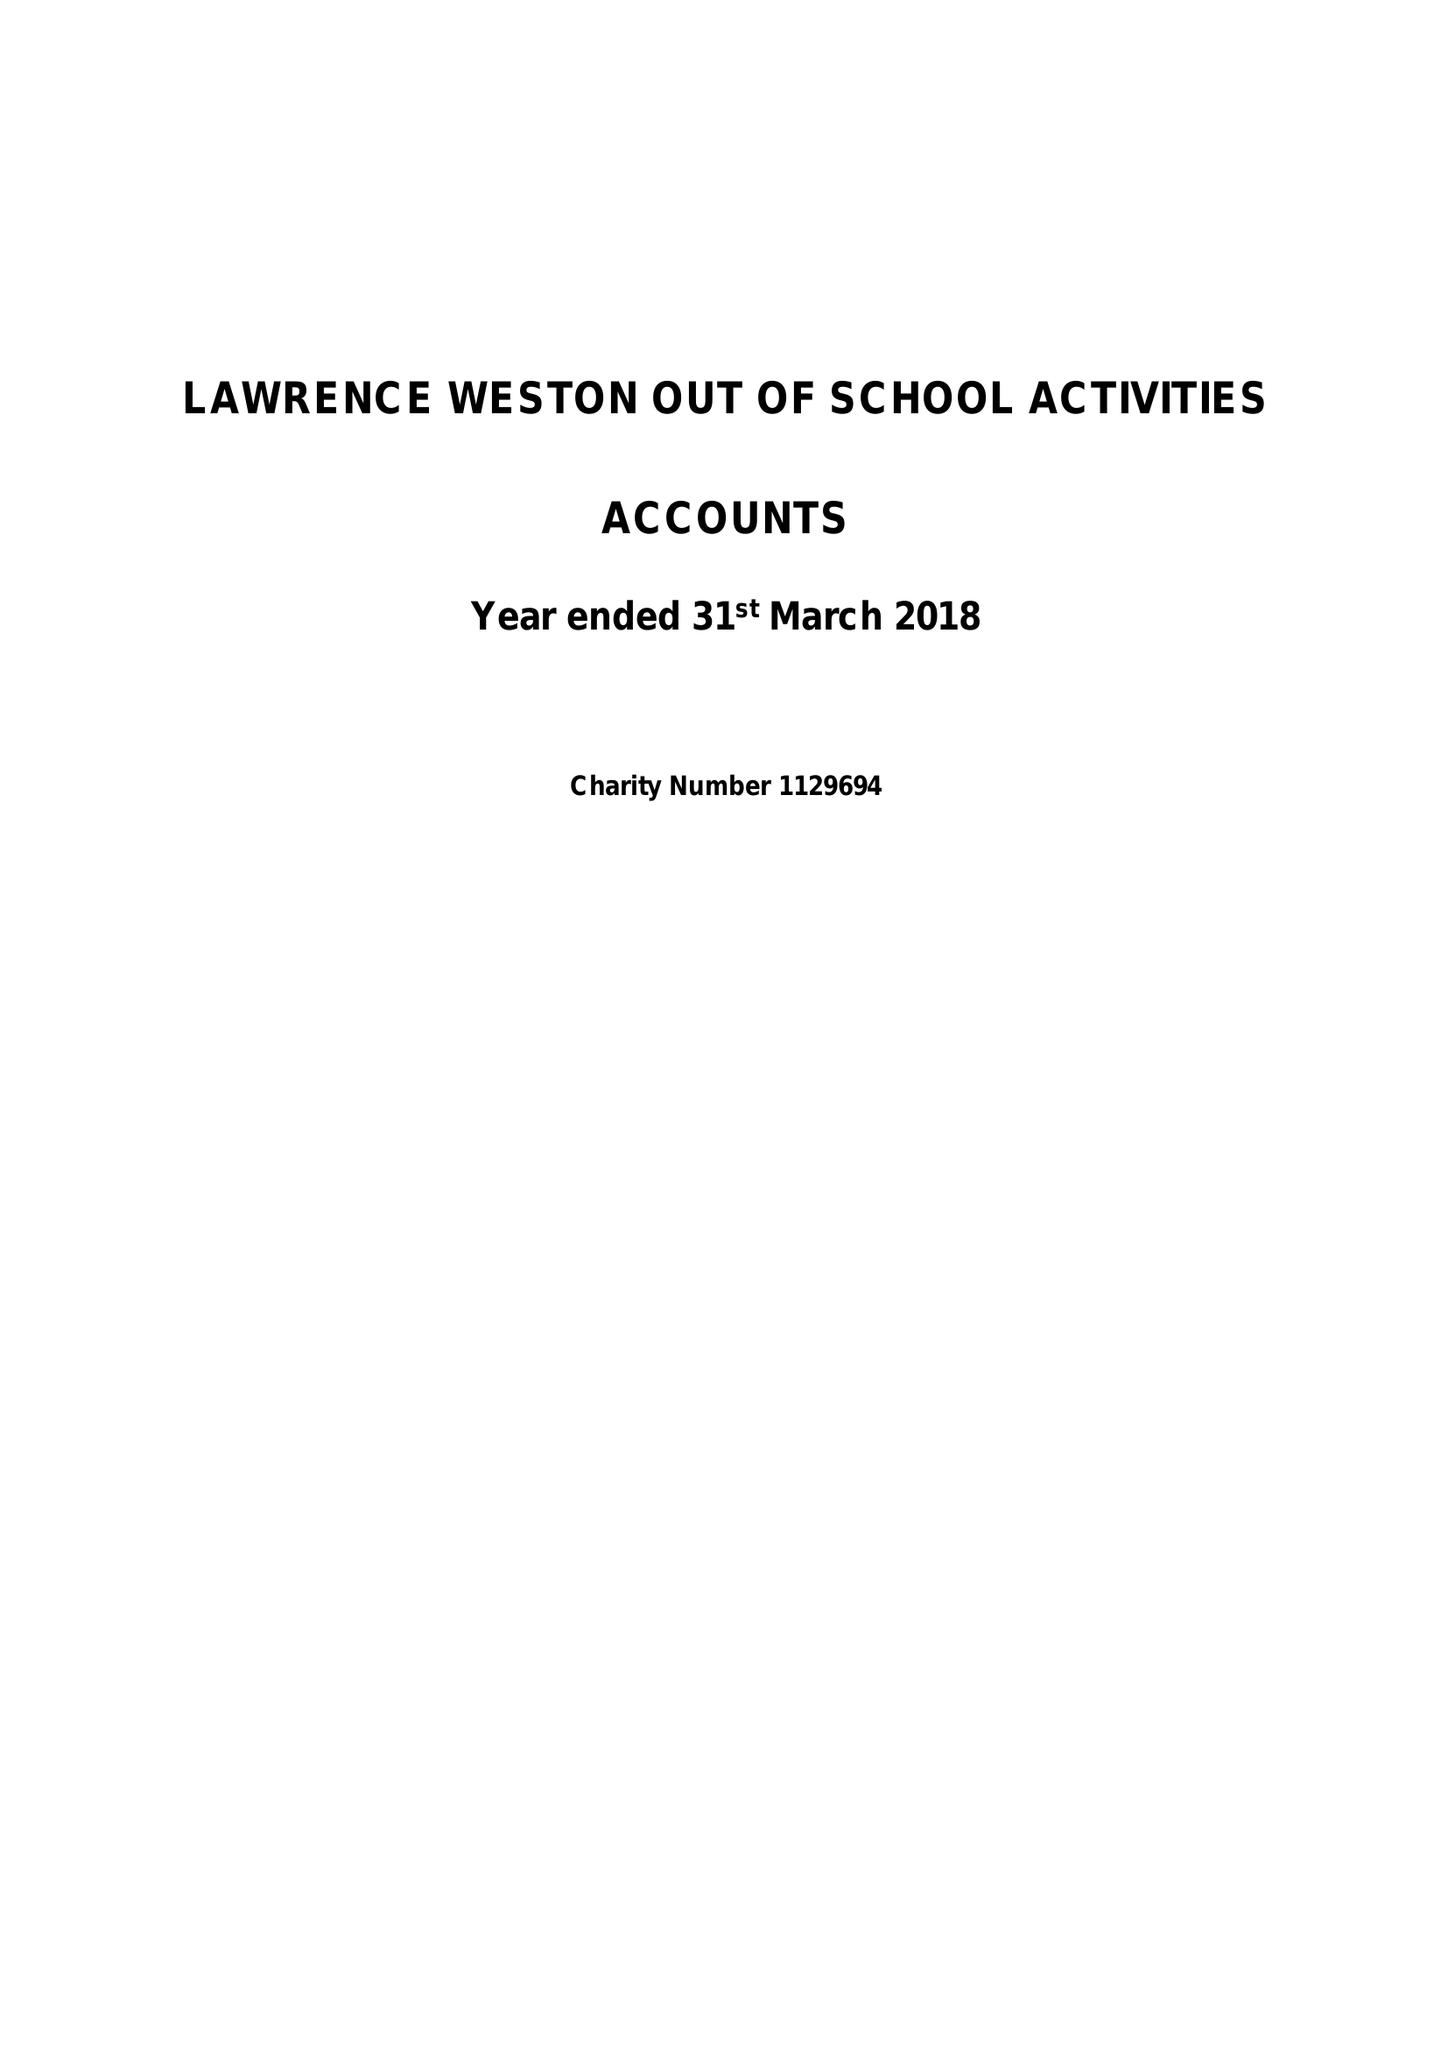What is the value for the charity_number?
Answer the question using a single word or phrase. 1129694 